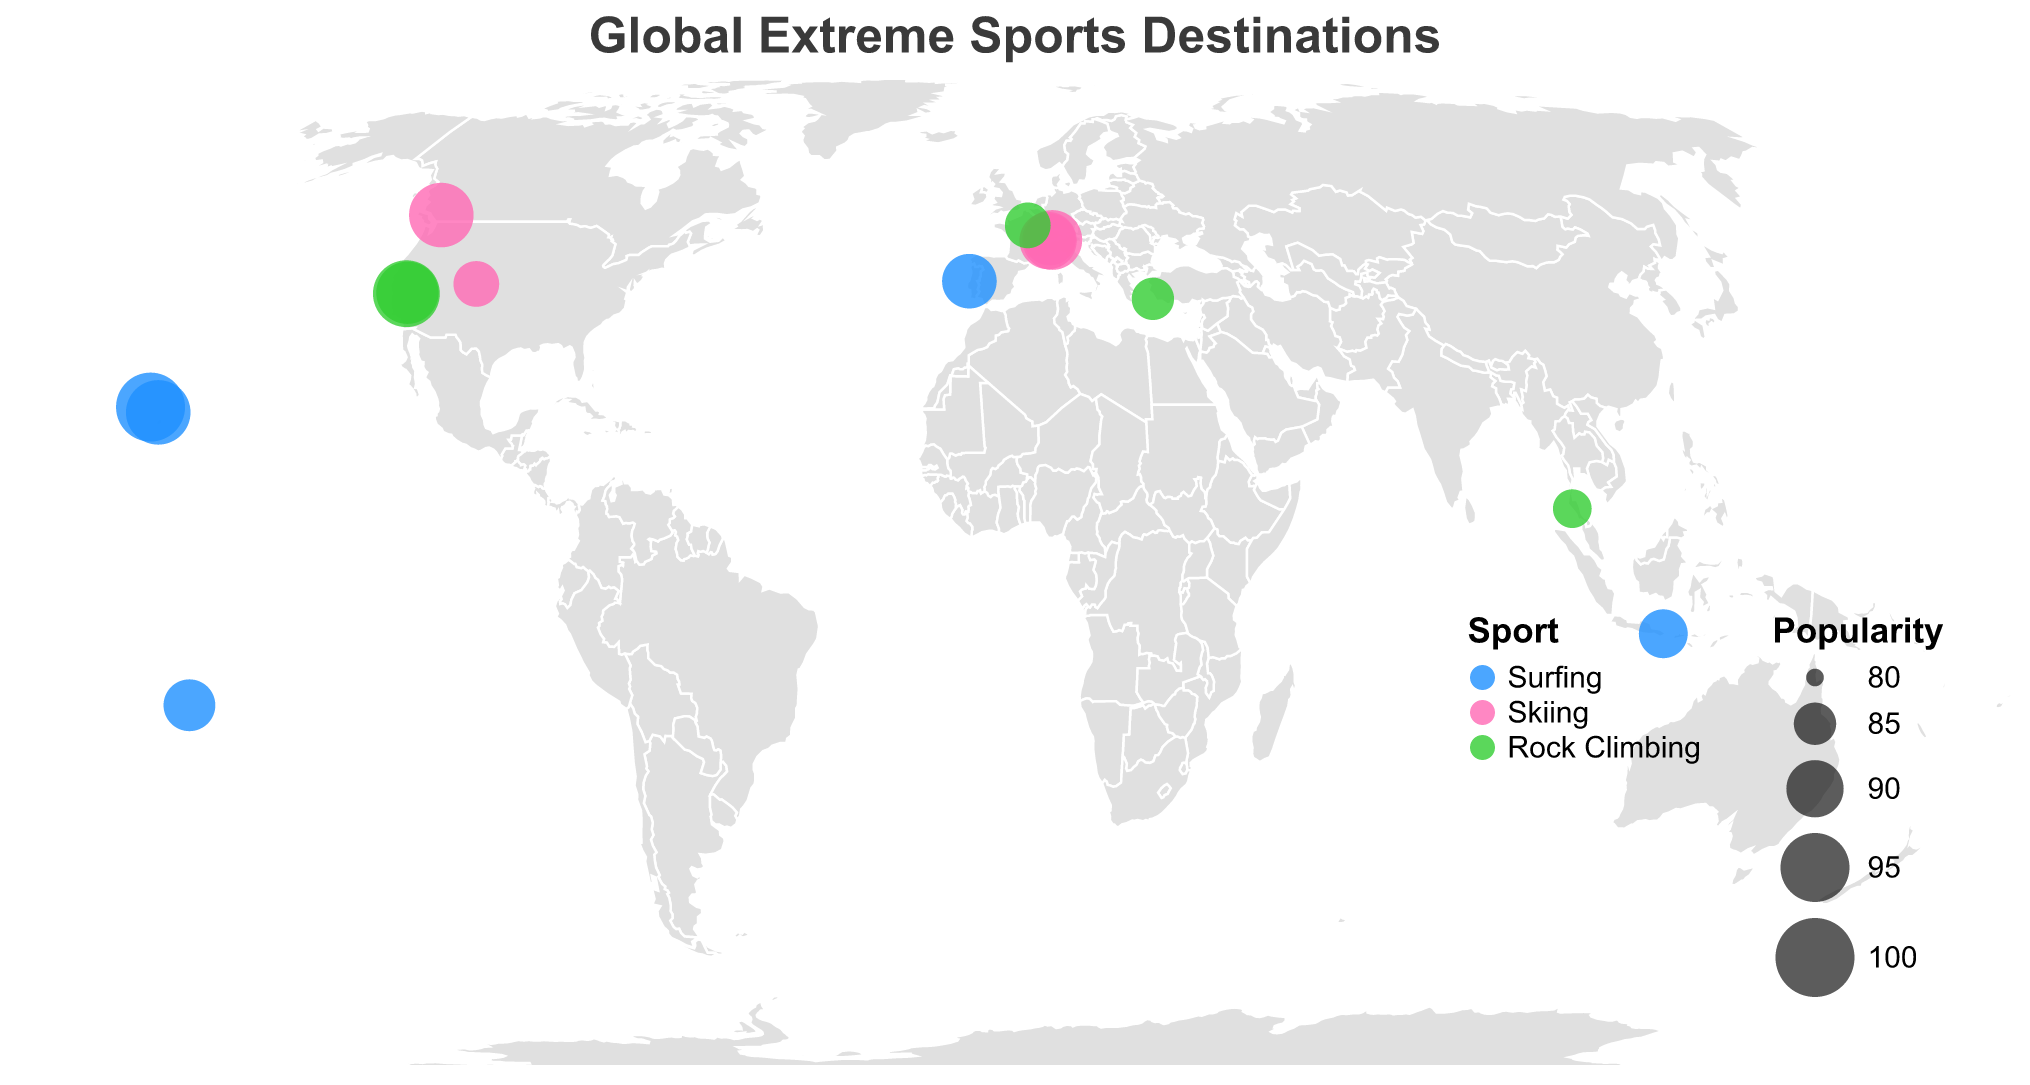What is the title of the figure? The title of the figure is displayed at the top center and reads "Global Extreme Sports Destinations".
Answer: Global Extreme Sports Destinations How many surfing locations are represented in the plot? By looking at the color-coded circles for the sport, the blue circles represent surfing spots. Counting those blue circles gives the total number of surfing locations.
Answer: 5 Which skiing location is the most popular according to the plot? The size of the circles indicates the popularity, and the circle with the largest size among the pink-colored skiing circles represents the most popular skiing location.
Answer: Whistler What are the coordinates of the least popular rock climbing destination in the plot? The green circles represent rock climbing spots, and the circle with the smallest size indicates the least popular destination. By checking the coordinates of the corresponding tooltips, we find Kalymnos is the least popular.
Answer: 36.9681, 26.9854 Which sport has the highest average popularity score? To determine this, we first find the average popularity for each sport by summing their popularity scores and dividing by the number of locations for that sport. Surfing (95+88+89+87+93)/5 = 90.4, Skiing (90+93+86+88+91)/5 = 89.6, Rock Climbing (92+85+94+84+86)/5 = 88.2. Therefore, surfing has the highest average popularity.
Answer: Surfing How many extreme sports locations are there in Europe on the plot? Examine the geographic distribution of locations and identify those within Europe by hovering over the map or looking at their coordinates. The European locations are Chamonix, Zermatt, Verbier, Fontainebleau, Kalymnos, and Nazaré. This gives a total of six locations.
Answer: 6 Which location has the highest popularity score in Asia? Checking the tooltips for the circles located within Asia, both Kalymnos and Krabi are rock climbing spots in Asia. Among them, Kalymnos has the highest popularity score of 85.
Answer: Kalymnos Compare the popularity of "Jaws" and "El Capitan". Which one is more popular? By hovering over their respective circles and reading their popularity scores, we see that "Jaws" has a popularity of 93, and "El Capitan" has a popularity of 94. Therefore, El Capitan is more popular.
Answer: El Capitan What are the names of all the extreme sports locations in the Southern Hemisphere shown in the plot? Identify the locations by checking the coordinates for negative latitudes, which include Teahupo'o and Bali.
Answer: Teahupo'o, Bali 